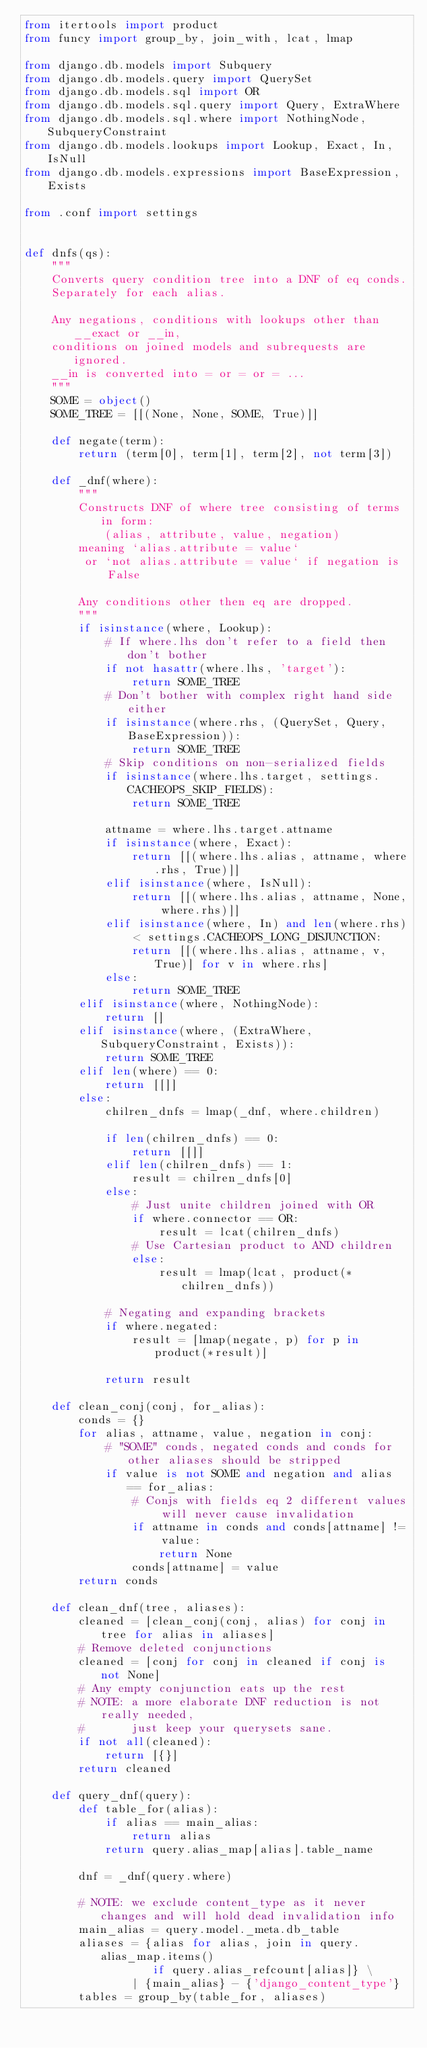<code> <loc_0><loc_0><loc_500><loc_500><_Python_>from itertools import product
from funcy import group_by, join_with, lcat, lmap

from django.db.models import Subquery
from django.db.models.query import QuerySet
from django.db.models.sql import OR
from django.db.models.sql.query import Query, ExtraWhere
from django.db.models.sql.where import NothingNode, SubqueryConstraint
from django.db.models.lookups import Lookup, Exact, In, IsNull
from django.db.models.expressions import BaseExpression, Exists

from .conf import settings


def dnfs(qs):
    """
    Converts query condition tree into a DNF of eq conds.
    Separately for each alias.

    Any negations, conditions with lookups other than __exact or __in,
    conditions on joined models and subrequests are ignored.
    __in is converted into = or = or = ...
    """
    SOME = object()
    SOME_TREE = [[(None, None, SOME, True)]]

    def negate(term):
        return (term[0], term[1], term[2], not term[3])

    def _dnf(where):
        """
        Constructs DNF of where tree consisting of terms in form:
            (alias, attribute, value, negation)
        meaning `alias.attribute = value`
         or `not alias.attribute = value` if negation is False

        Any conditions other then eq are dropped.
        """
        if isinstance(where, Lookup):
            # If where.lhs don't refer to a field then don't bother
            if not hasattr(where.lhs, 'target'):
                return SOME_TREE
            # Don't bother with complex right hand side either
            if isinstance(where.rhs, (QuerySet, Query, BaseExpression)):
                return SOME_TREE
            # Skip conditions on non-serialized fields
            if isinstance(where.lhs.target, settings.CACHEOPS_SKIP_FIELDS):
                return SOME_TREE

            attname = where.lhs.target.attname
            if isinstance(where, Exact):
                return [[(where.lhs.alias, attname, where.rhs, True)]]
            elif isinstance(where, IsNull):
                return [[(where.lhs.alias, attname, None, where.rhs)]]
            elif isinstance(where, In) and len(where.rhs) < settings.CACHEOPS_LONG_DISJUNCTION:
                return [[(where.lhs.alias, attname, v, True)] for v in where.rhs]
            else:
                return SOME_TREE
        elif isinstance(where, NothingNode):
            return []
        elif isinstance(where, (ExtraWhere, SubqueryConstraint, Exists)):
            return SOME_TREE
        elif len(where) == 0:
            return [[]]
        else:
            chilren_dnfs = lmap(_dnf, where.children)

            if len(chilren_dnfs) == 0:
                return [[]]
            elif len(chilren_dnfs) == 1:
                result = chilren_dnfs[0]
            else:
                # Just unite children joined with OR
                if where.connector == OR:
                    result = lcat(chilren_dnfs)
                # Use Cartesian product to AND children
                else:
                    result = lmap(lcat, product(*chilren_dnfs))

            # Negating and expanding brackets
            if where.negated:
                result = [lmap(negate, p) for p in product(*result)]

            return result

    def clean_conj(conj, for_alias):
        conds = {}
        for alias, attname, value, negation in conj:
            # "SOME" conds, negated conds and conds for other aliases should be stripped
            if value is not SOME and negation and alias == for_alias:
                # Conjs with fields eq 2 different values will never cause invalidation
                if attname in conds and conds[attname] != value:
                    return None
                conds[attname] = value
        return conds

    def clean_dnf(tree, aliases):
        cleaned = [clean_conj(conj, alias) for conj in tree for alias in aliases]
        # Remove deleted conjunctions
        cleaned = [conj for conj in cleaned if conj is not None]
        # Any empty conjunction eats up the rest
        # NOTE: a more elaborate DNF reduction is not really needed,
        #       just keep your querysets sane.
        if not all(cleaned):
            return [{}]
        return cleaned

    def query_dnf(query):
        def table_for(alias):
            if alias == main_alias:
                return alias
            return query.alias_map[alias].table_name

        dnf = _dnf(query.where)

        # NOTE: we exclude content_type as it never changes and will hold dead invalidation info
        main_alias = query.model._meta.db_table
        aliases = {alias for alias, join in query.alias_map.items()
                   if query.alias_refcount[alias]} \
                | {main_alias} - {'django_content_type'}
        tables = group_by(table_for, aliases)</code> 